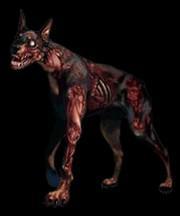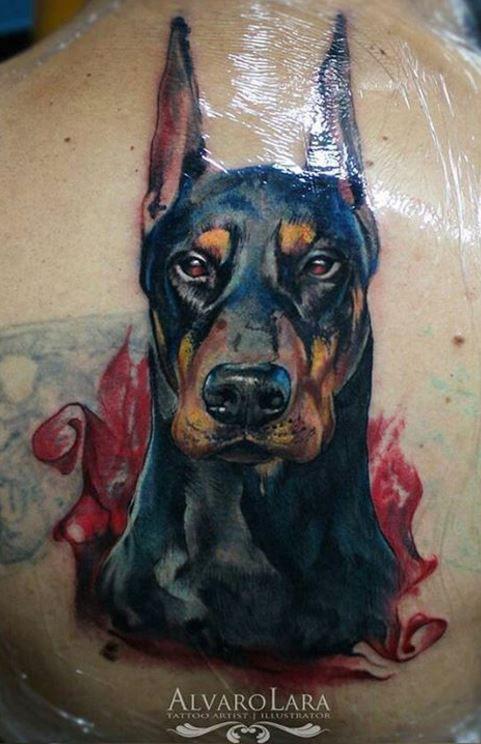The first image is the image on the left, the second image is the image on the right. For the images displayed, is the sentence "In both drawings the doberman's mouth is open." factually correct? Answer yes or no. No. The first image is the image on the left, the second image is the image on the right. For the images shown, is this caption "The left and right image contains the same number of dog head tattoos." true? Answer yes or no. No. 